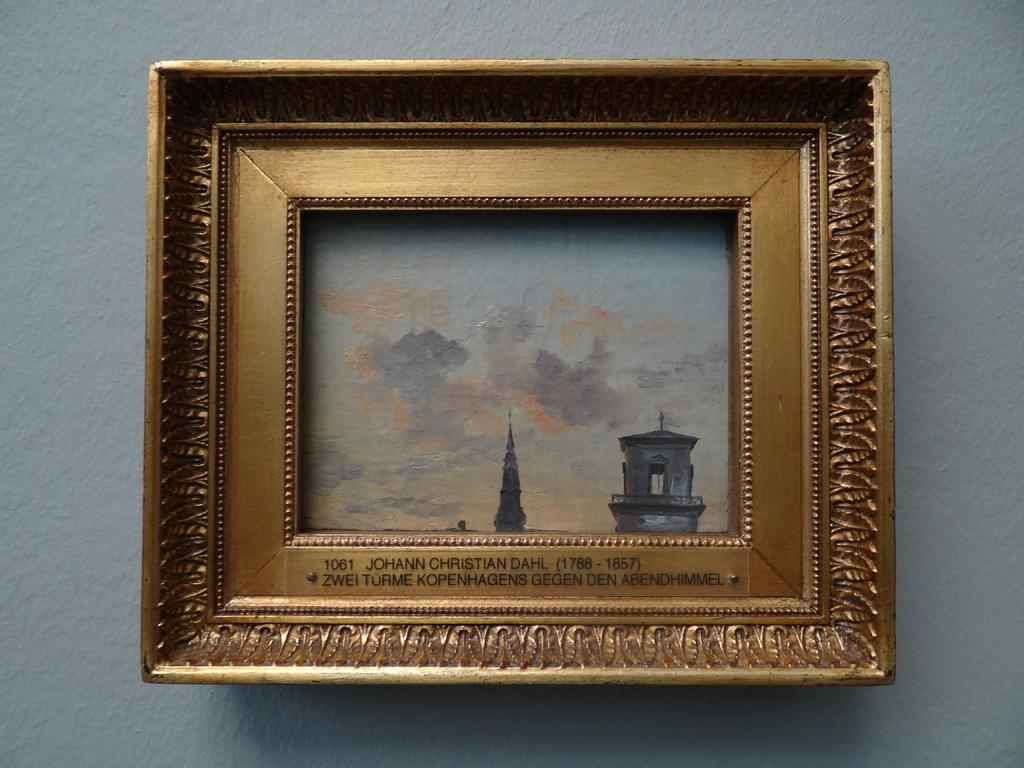Provide a one-sentence caption for the provided image. An intricate frame that says Johann Christian Dahl on it. 